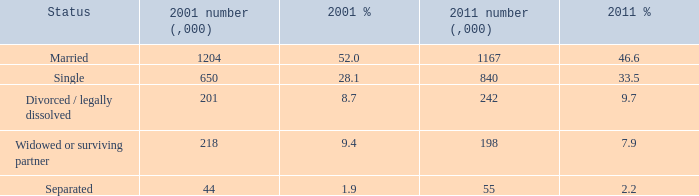Could you help me parse every detail presented in this table? {'header': ['Status', '2001 number (,000)', '2001 %', '2011 number (,000)', '2011 %'], 'rows': [['Married', '1204', '52.0', '1167', '46.6'], ['Single', '650', '28.1', '840', '33.5'], ['Divorced / legally dissolved', '201', '8.7', '242', '9.7'], ['Widowed or surviving partner', '218', '9.4', '198', '7.9'], ['Separated', '44', '1.9', '55', '2.2']]} What is the 2011 value (,000) when the status is split? 55.0. 